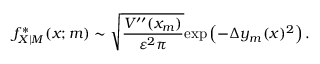Convert formula to latex. <formula><loc_0><loc_0><loc_500><loc_500>f _ { X | M } ^ { * } ( x ; m ) \sim \sqrt { \frac { V ^ { \prime \prime } ( x _ { m } ) } { \varepsilon ^ { 2 } \pi } } e x p \left ( - \Delta y _ { m } ( x ) ^ { 2 } \right ) .</formula> 